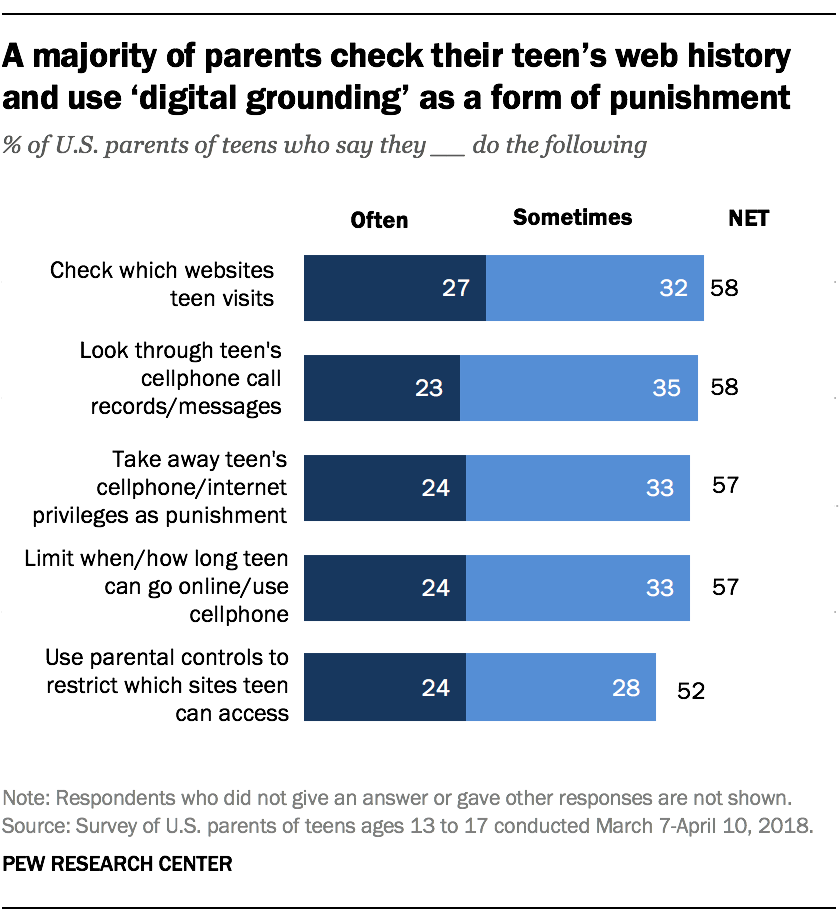Indicate a few pertinent items in this graphic. What is the value of the first light blue bar from the top? There are three navy blue bars that have a value of 24. 